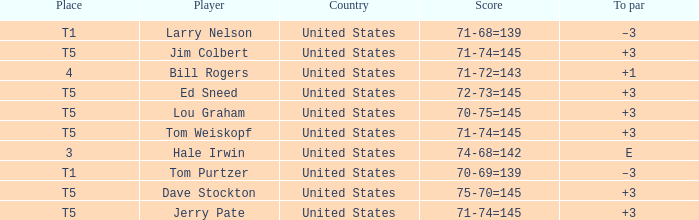Who is the player with a 70-75=145 score? Lou Graham. Could you parse the entire table? {'header': ['Place', 'Player', 'Country', 'Score', 'To par'], 'rows': [['T1', 'Larry Nelson', 'United States', '71-68=139', '–3'], ['T5', 'Jim Colbert', 'United States', '71-74=145', '+3'], ['4', 'Bill Rogers', 'United States', '71-72=143', '+1'], ['T5', 'Ed Sneed', 'United States', '72-73=145', '+3'], ['T5', 'Lou Graham', 'United States', '70-75=145', '+3'], ['T5', 'Tom Weiskopf', 'United States', '71-74=145', '+3'], ['3', 'Hale Irwin', 'United States', '74-68=142', 'E'], ['T1', 'Tom Purtzer', 'United States', '70-69=139', '–3'], ['T5', 'Dave Stockton', 'United States', '75-70=145', '+3'], ['T5', 'Jerry Pate', 'United States', '71-74=145', '+3']]} 